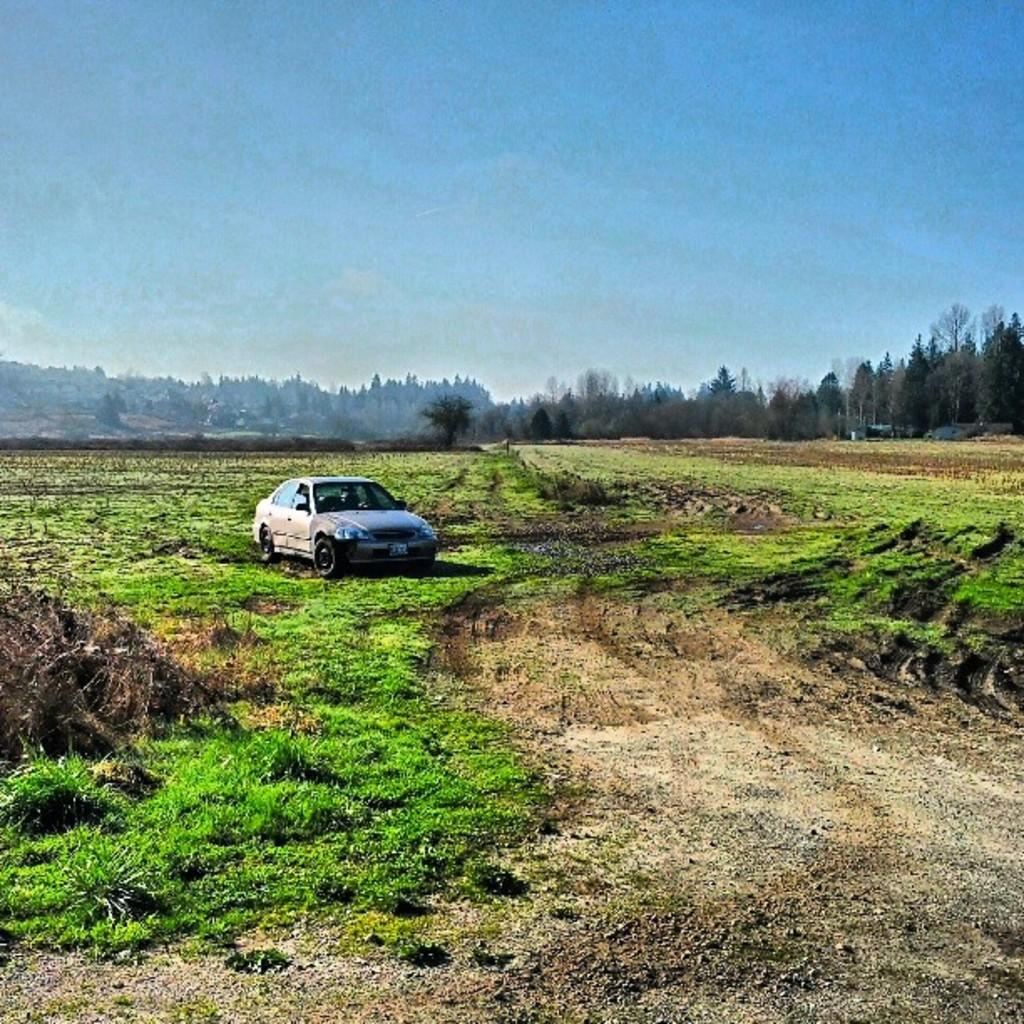What type of vehicle is located on the left side of the image? There is an old car on the left side of the image. What can be seen in the center of the image? There is greenery in the center of the image. What is visible at the top of the image? The sky is visible at the top of the image. What flavor of gum is the person chewing in the image? There is no person or gum present in the image. How many items are in the person's pocket in the image? There is no person or pocket present in the image. 